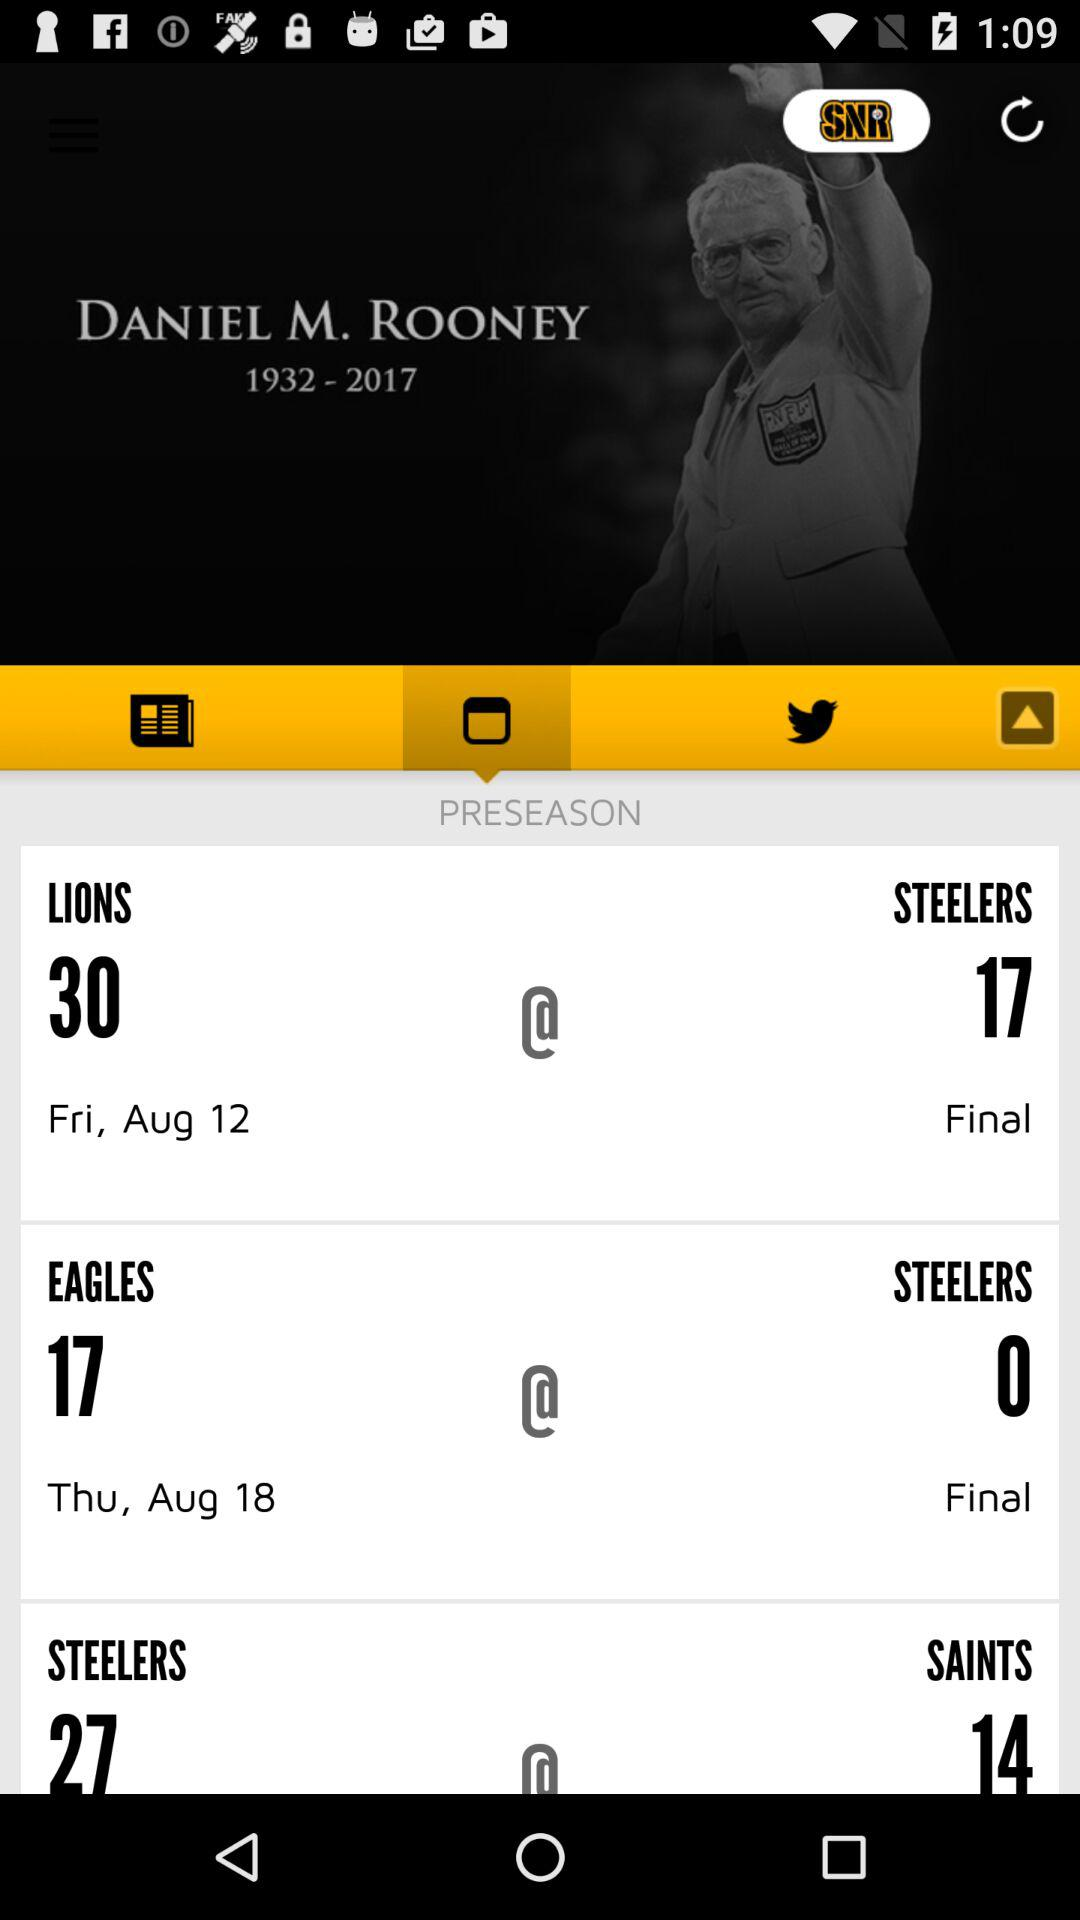How many games are in the preseason?
Answer the question using a single word or phrase. 3 